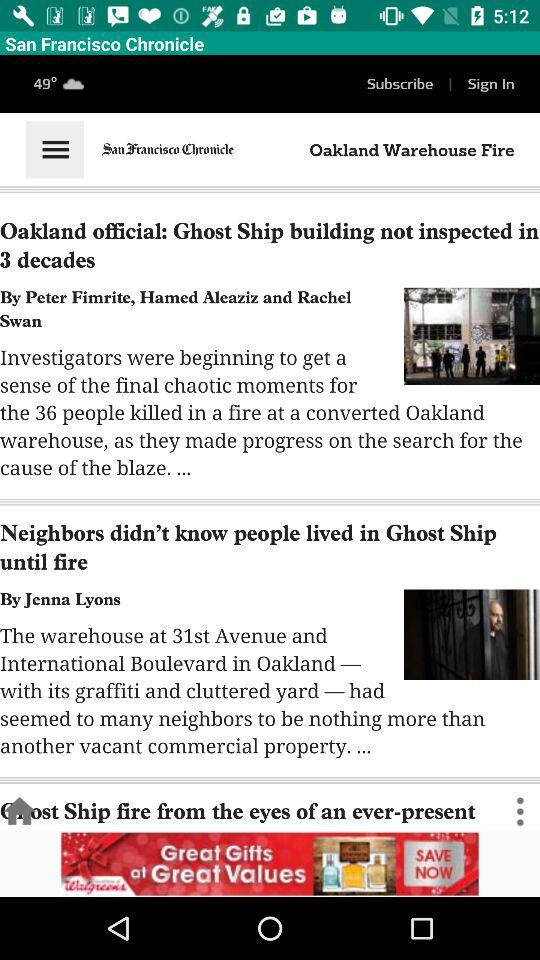What is the temperature? The temperature is 49 degrees. 